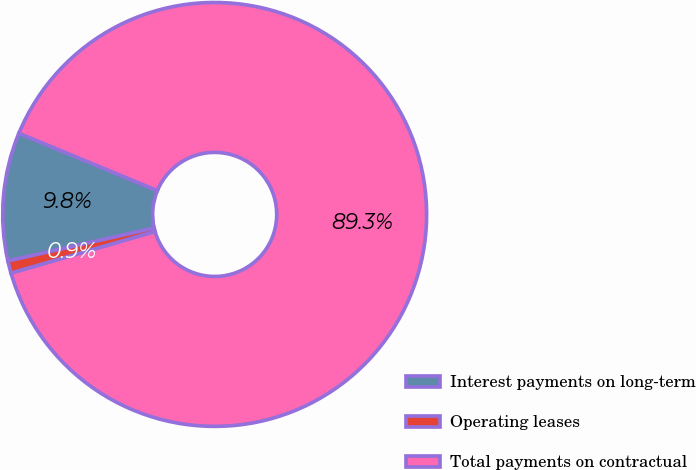<chart> <loc_0><loc_0><loc_500><loc_500><pie_chart><fcel>Interest payments on long-term<fcel>Operating leases<fcel>Total payments on contractual<nl><fcel>9.78%<fcel>0.95%<fcel>89.28%<nl></chart> 